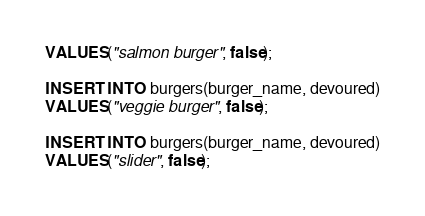Convert code to text. <code><loc_0><loc_0><loc_500><loc_500><_SQL_>VALUES("salmon burger", false);

INSERT INTO burgers(burger_name, devoured)
VALUES("veggie burger", false);

INSERT INTO burgers(burger_name, devoured)
VALUES("slider", false);</code> 